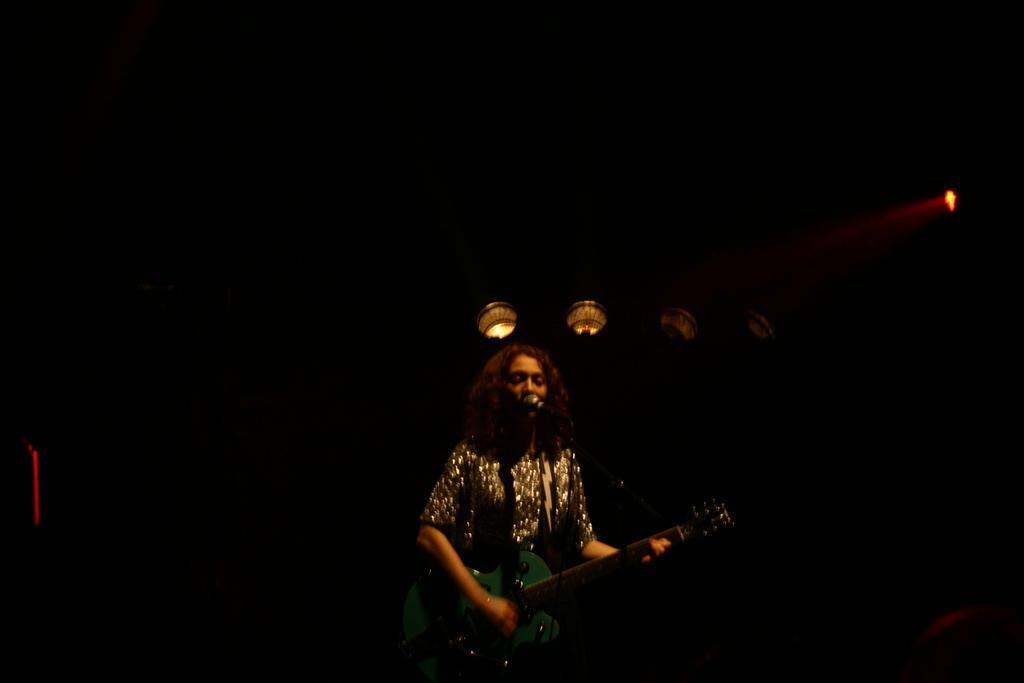How would you summarize this image in a sentence or two? In the foreground of this image, there is a woman standing in front of a mic and playing guitar. In the background, there are few lights in the dark. 